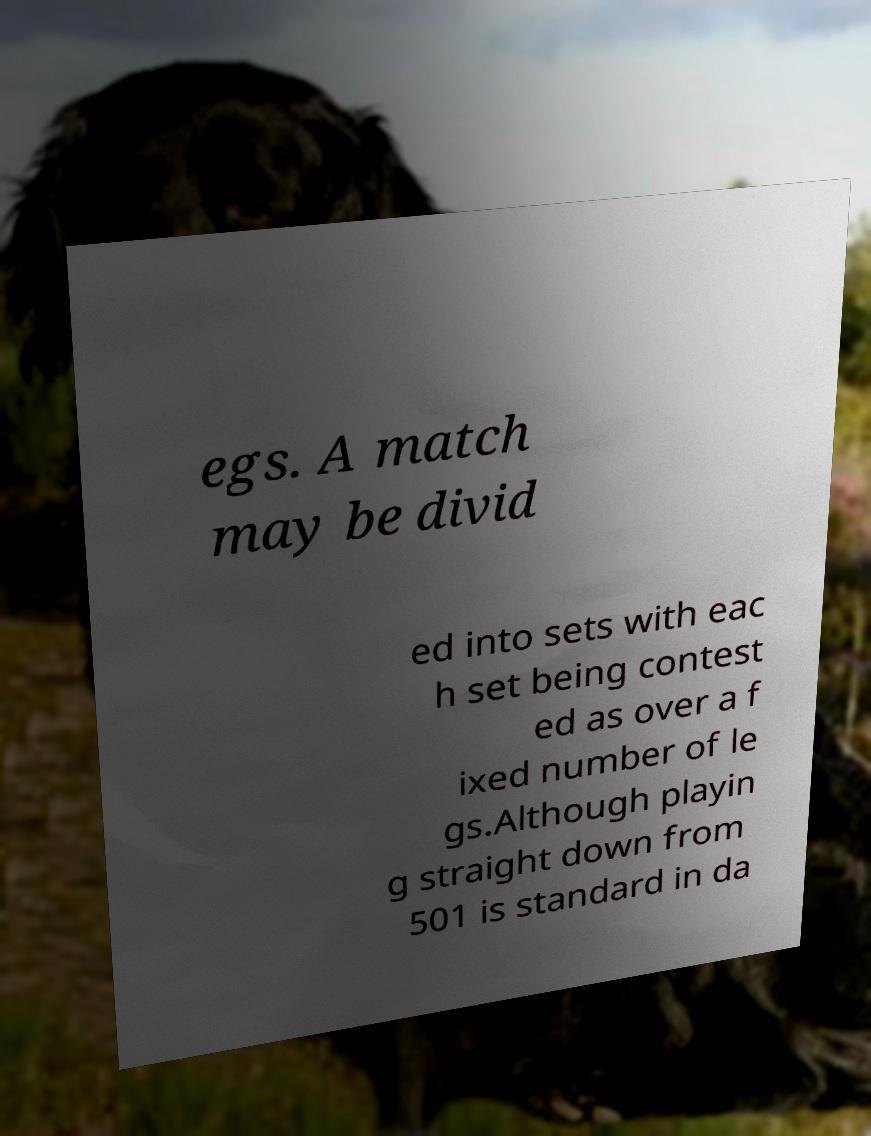I need the written content from this picture converted into text. Can you do that? egs. A match may be divid ed into sets with eac h set being contest ed as over a f ixed number of le gs.Although playin g straight down from 501 is standard in da 